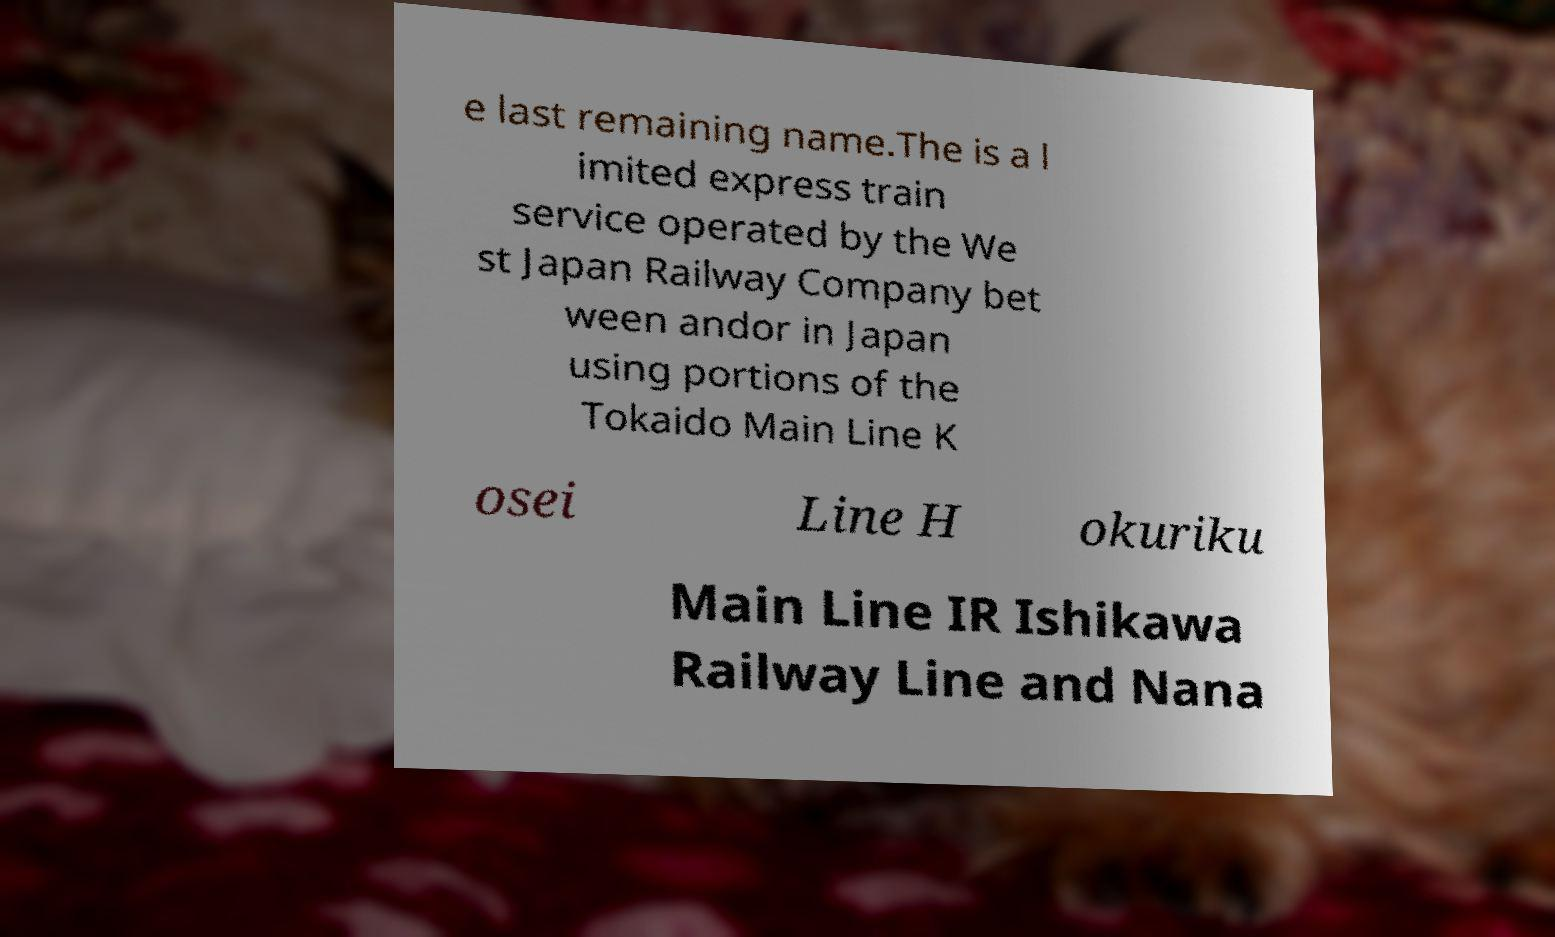For documentation purposes, I need the text within this image transcribed. Could you provide that? e last remaining name.The is a l imited express train service operated by the We st Japan Railway Company bet ween andor in Japan using portions of the Tokaido Main Line K osei Line H okuriku Main Line IR Ishikawa Railway Line and Nana 